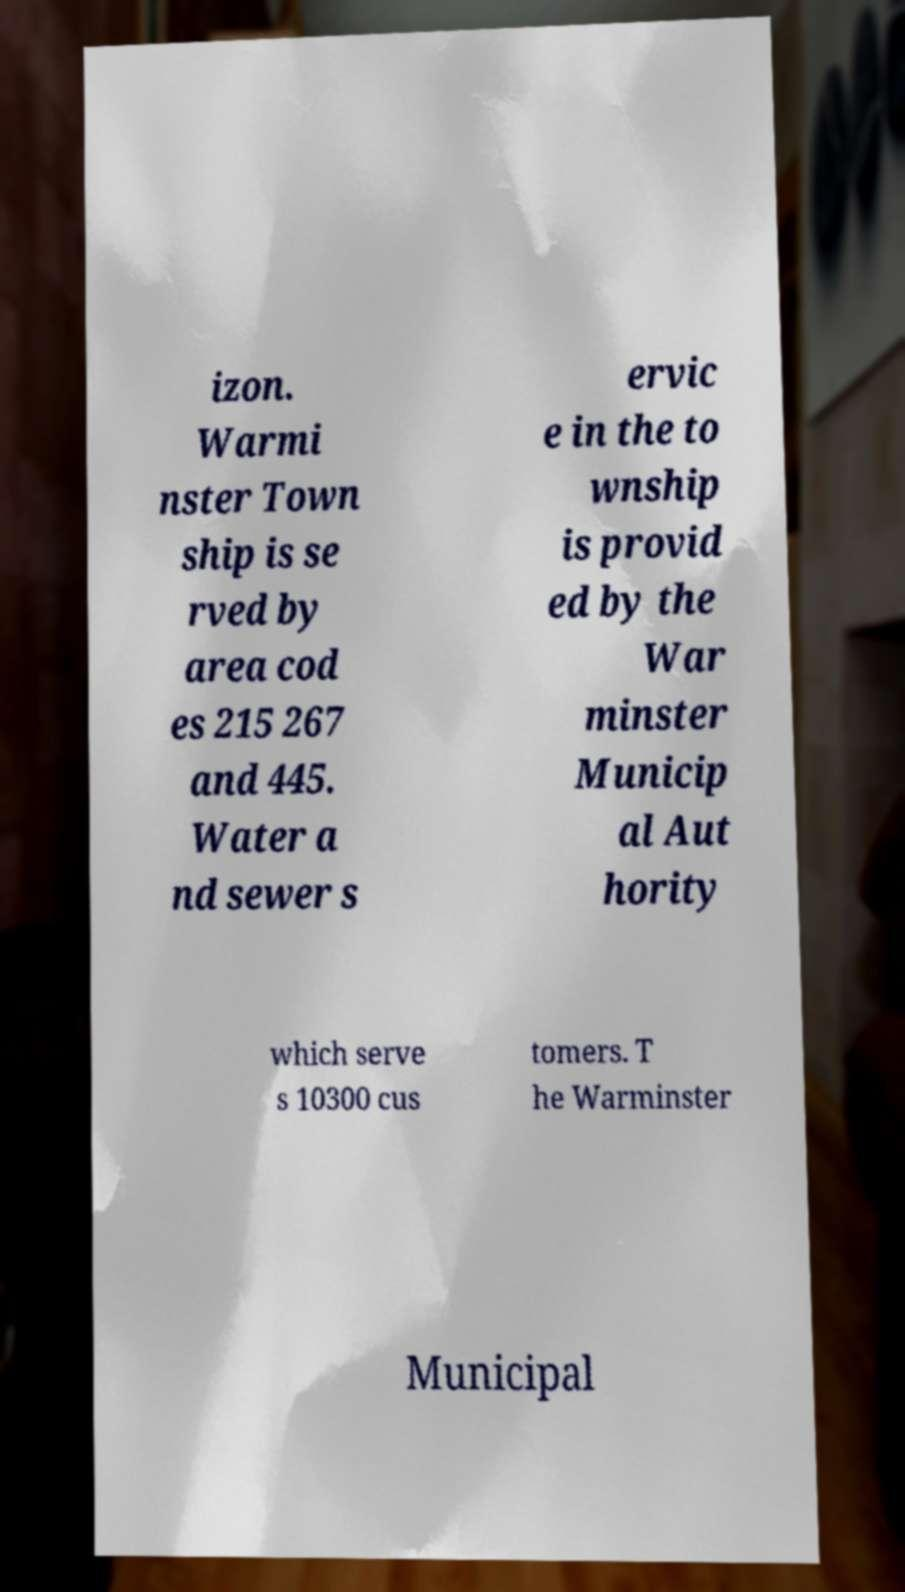I need the written content from this picture converted into text. Can you do that? izon. Warmi nster Town ship is se rved by area cod es 215 267 and 445. Water a nd sewer s ervic e in the to wnship is provid ed by the War minster Municip al Aut hority which serve s 10300 cus tomers. T he Warminster Municipal 